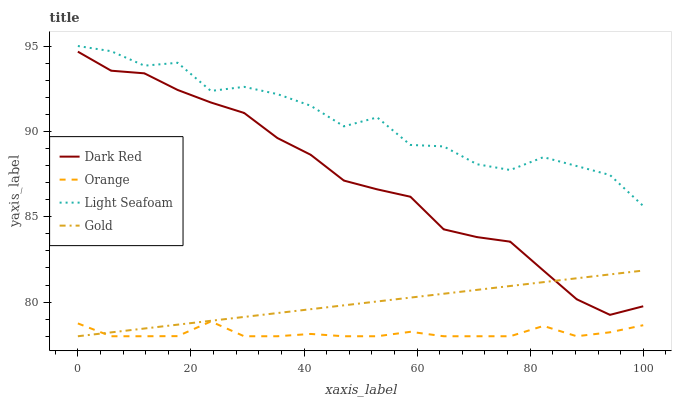Does Dark Red have the minimum area under the curve?
Answer yes or no. No. Does Dark Red have the maximum area under the curve?
Answer yes or no. No. Is Dark Red the smoothest?
Answer yes or no. No. Is Dark Red the roughest?
Answer yes or no. No. Does Dark Red have the lowest value?
Answer yes or no. No. Does Dark Red have the highest value?
Answer yes or no. No. Is Dark Red less than Light Seafoam?
Answer yes or no. Yes. Is Light Seafoam greater than Gold?
Answer yes or no. Yes. Does Dark Red intersect Light Seafoam?
Answer yes or no. No. 